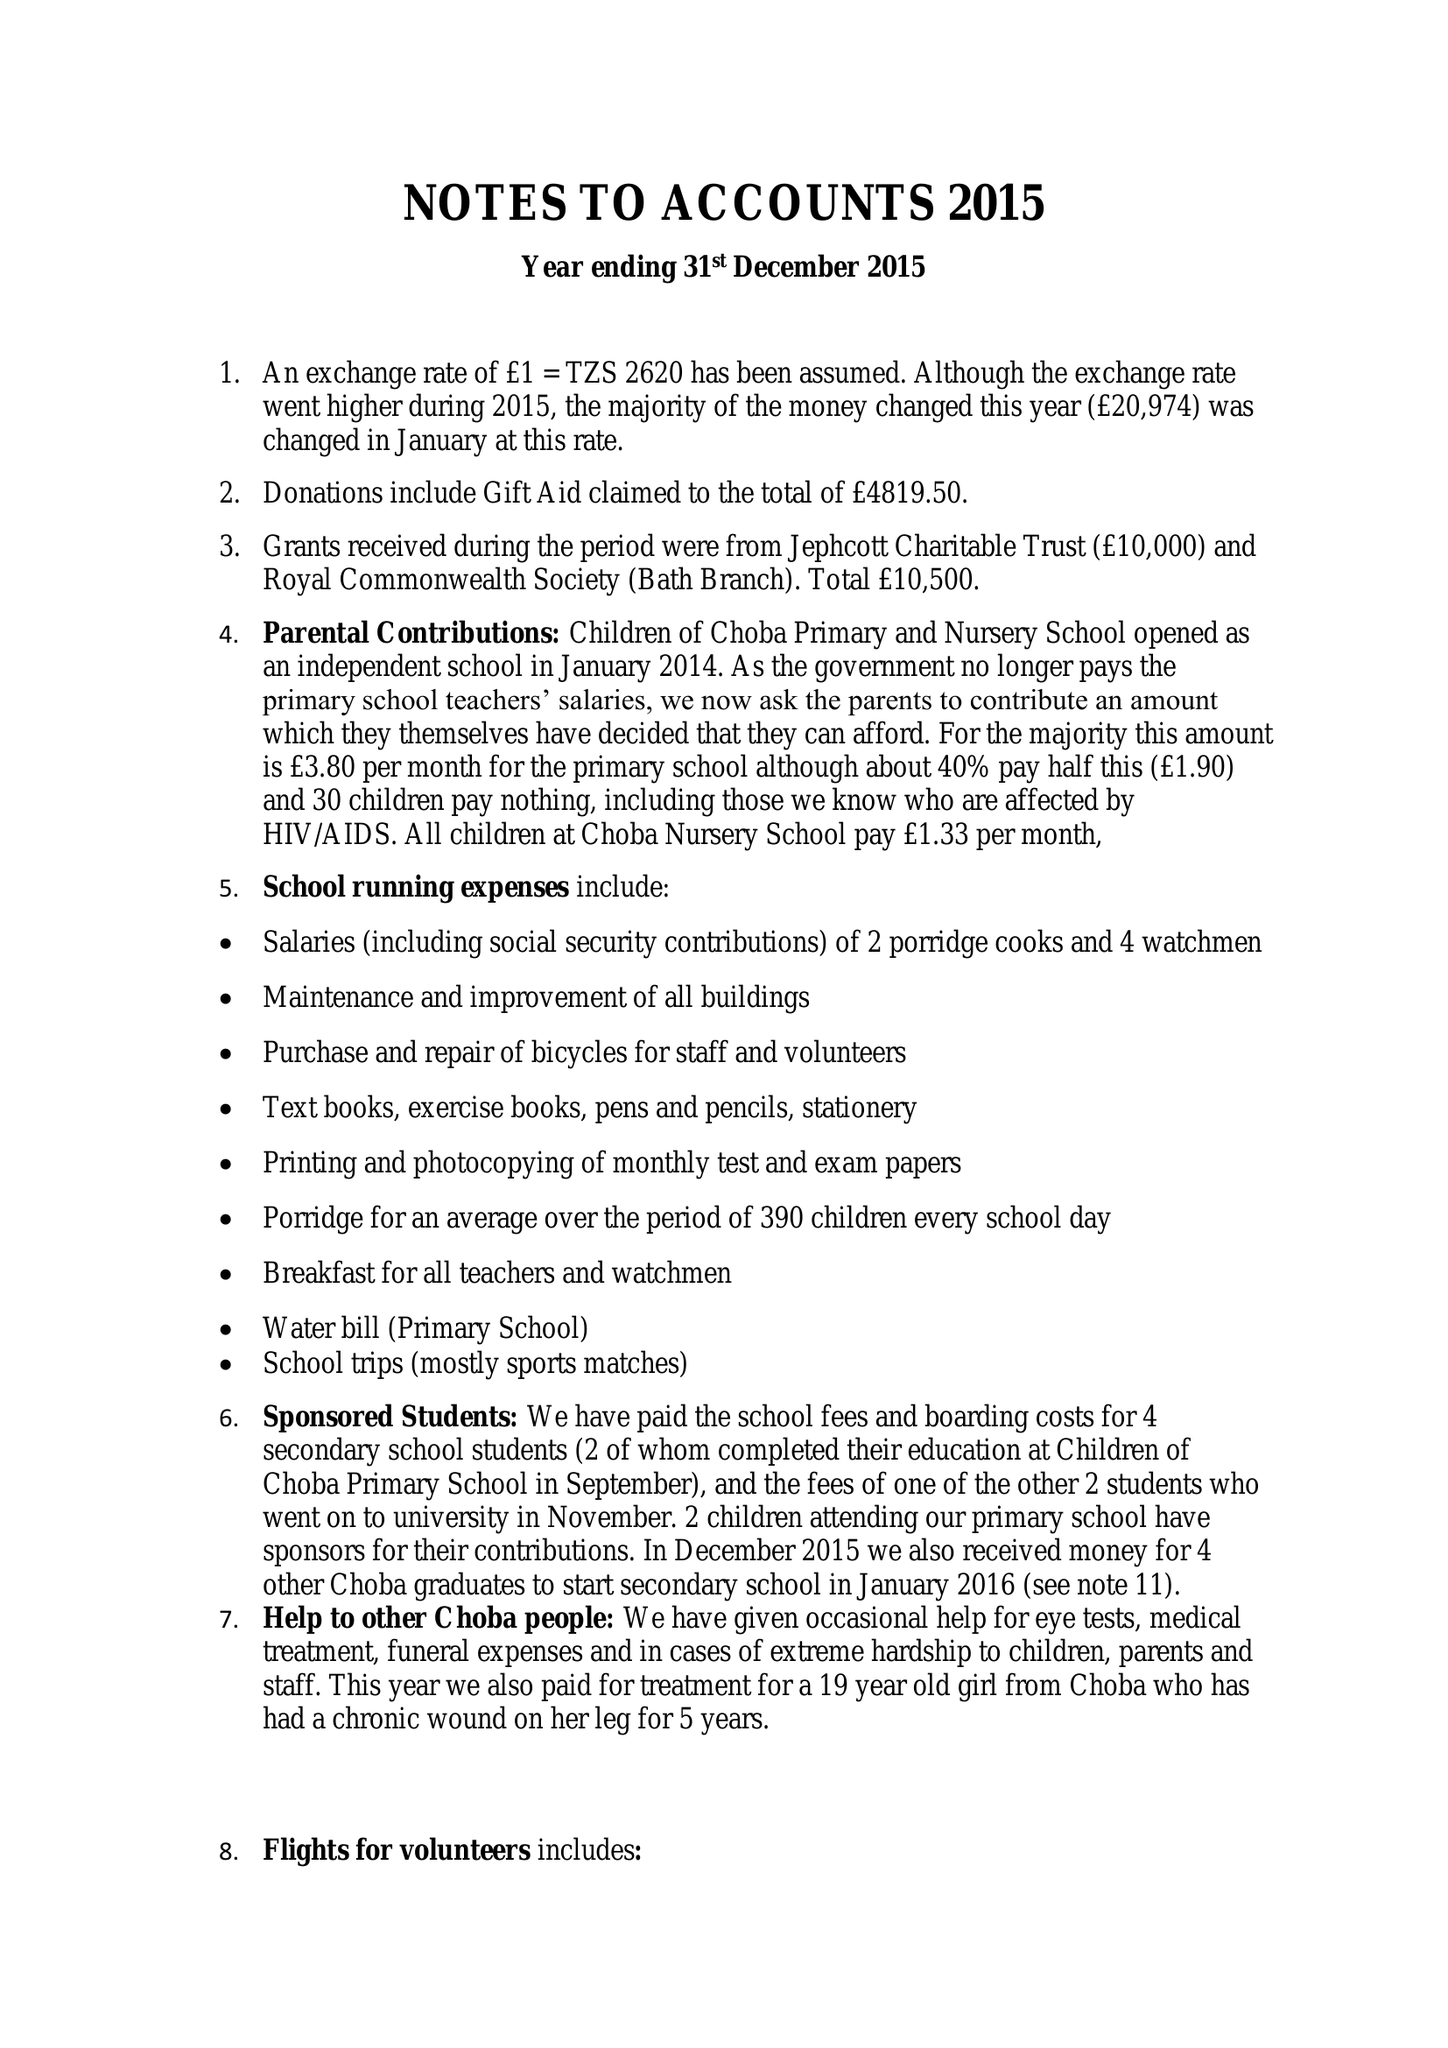What is the value for the report_date?
Answer the question using a single word or phrase. 2015-12-31 